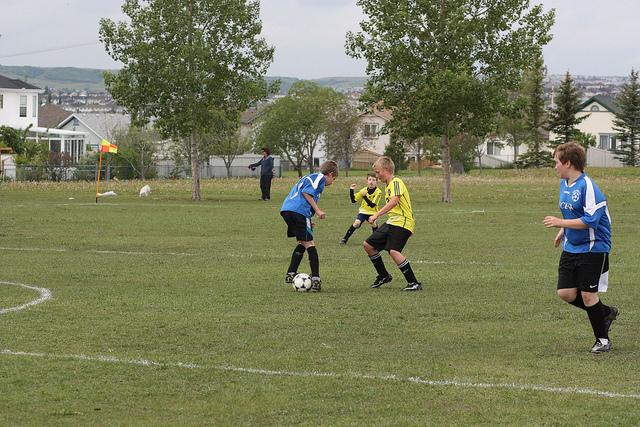Where is the ball?
Be succinct. Ground. Are these children or adults?
Concise answer only. Children. What store is in the background?
Quick response, please. None. Does soccer require lots of running?
Write a very short answer. Yes. Are all the boys in the picture on the same team?
Write a very short answer. No. Which game is being played?
Write a very short answer. Soccer. What are these boys doing?
Answer briefly. Playing soccer. What is this sport?
Keep it brief. Soccer. 